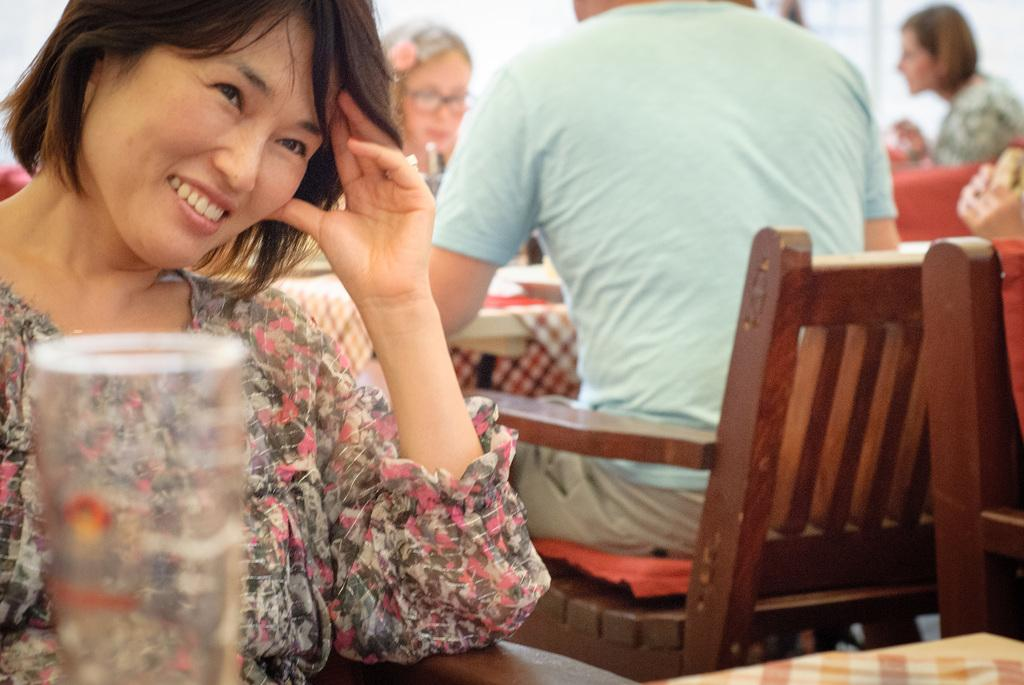What is the primary subject of the image? There is a woman sitting in the image. Can you describe the surrounding environment or context? There are multiple people sitting in chairs behind the woman. What type of nut is being washed in the image? There is no nut or washing activity present in the image. 